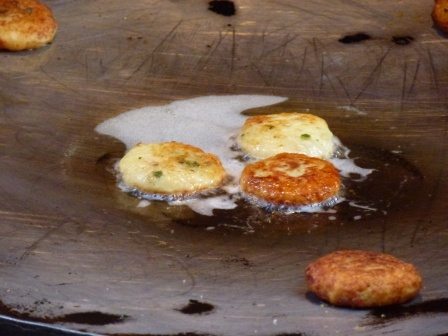Can you give me a more detailed breakdown of the cooking process that might have led to this scene? Certainly! The process likely began with a well-heated frying pan, to which a generous amount of oil was added. The pancake batter, enriched with chives, was then spooned into the pan in small rounds. The cook probably monitored the heat to ensure the pancakes cooked evenly, adjusting the flame as needed.

The pancakes gradually developed their golden-brown color as they cooked, the oil creating a crispy exterior while keeping the inside soft and fluffy. The different shades of brown indicate varying stages of doneness: the darker ones have been sizzling longer, allowing a richer, deeper crispness, while the lighter ones were added later or are cooking at a slightly different rate due to the pan's heat distribution.

The slight batter splatter around the edges hints at the care taken to avoid overcrowding the pan, ensuring each pancake had enough space to cook properly. This attentive cooking likely resulted in the aromatic, appealing pancakes seen in the image, ready to be enjoyed as a delicious breakfast or snack. 